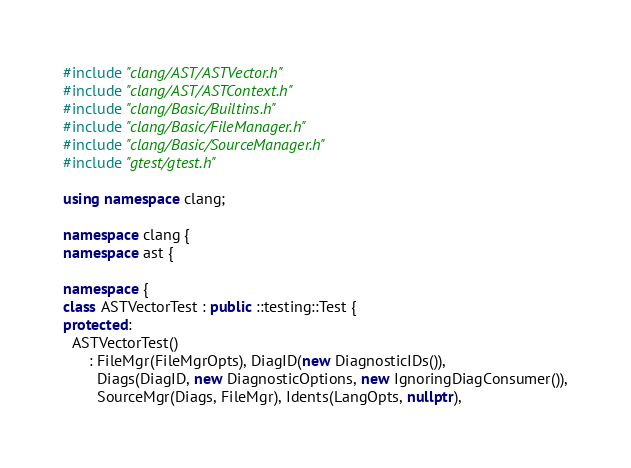Convert code to text. <code><loc_0><loc_0><loc_500><loc_500><_C++_>
#include "clang/AST/ASTVector.h"
#include "clang/AST/ASTContext.h"
#include "clang/Basic/Builtins.h"
#include "clang/Basic/FileManager.h"
#include "clang/Basic/SourceManager.h"
#include "gtest/gtest.h"

using namespace clang;

namespace clang {
namespace ast {

namespace {
class ASTVectorTest : public ::testing::Test {
protected:
  ASTVectorTest()
      : FileMgr(FileMgrOpts), DiagID(new DiagnosticIDs()),
        Diags(DiagID, new DiagnosticOptions, new IgnoringDiagConsumer()),
        SourceMgr(Diags, FileMgr), Idents(LangOpts, nullptr),</code> 